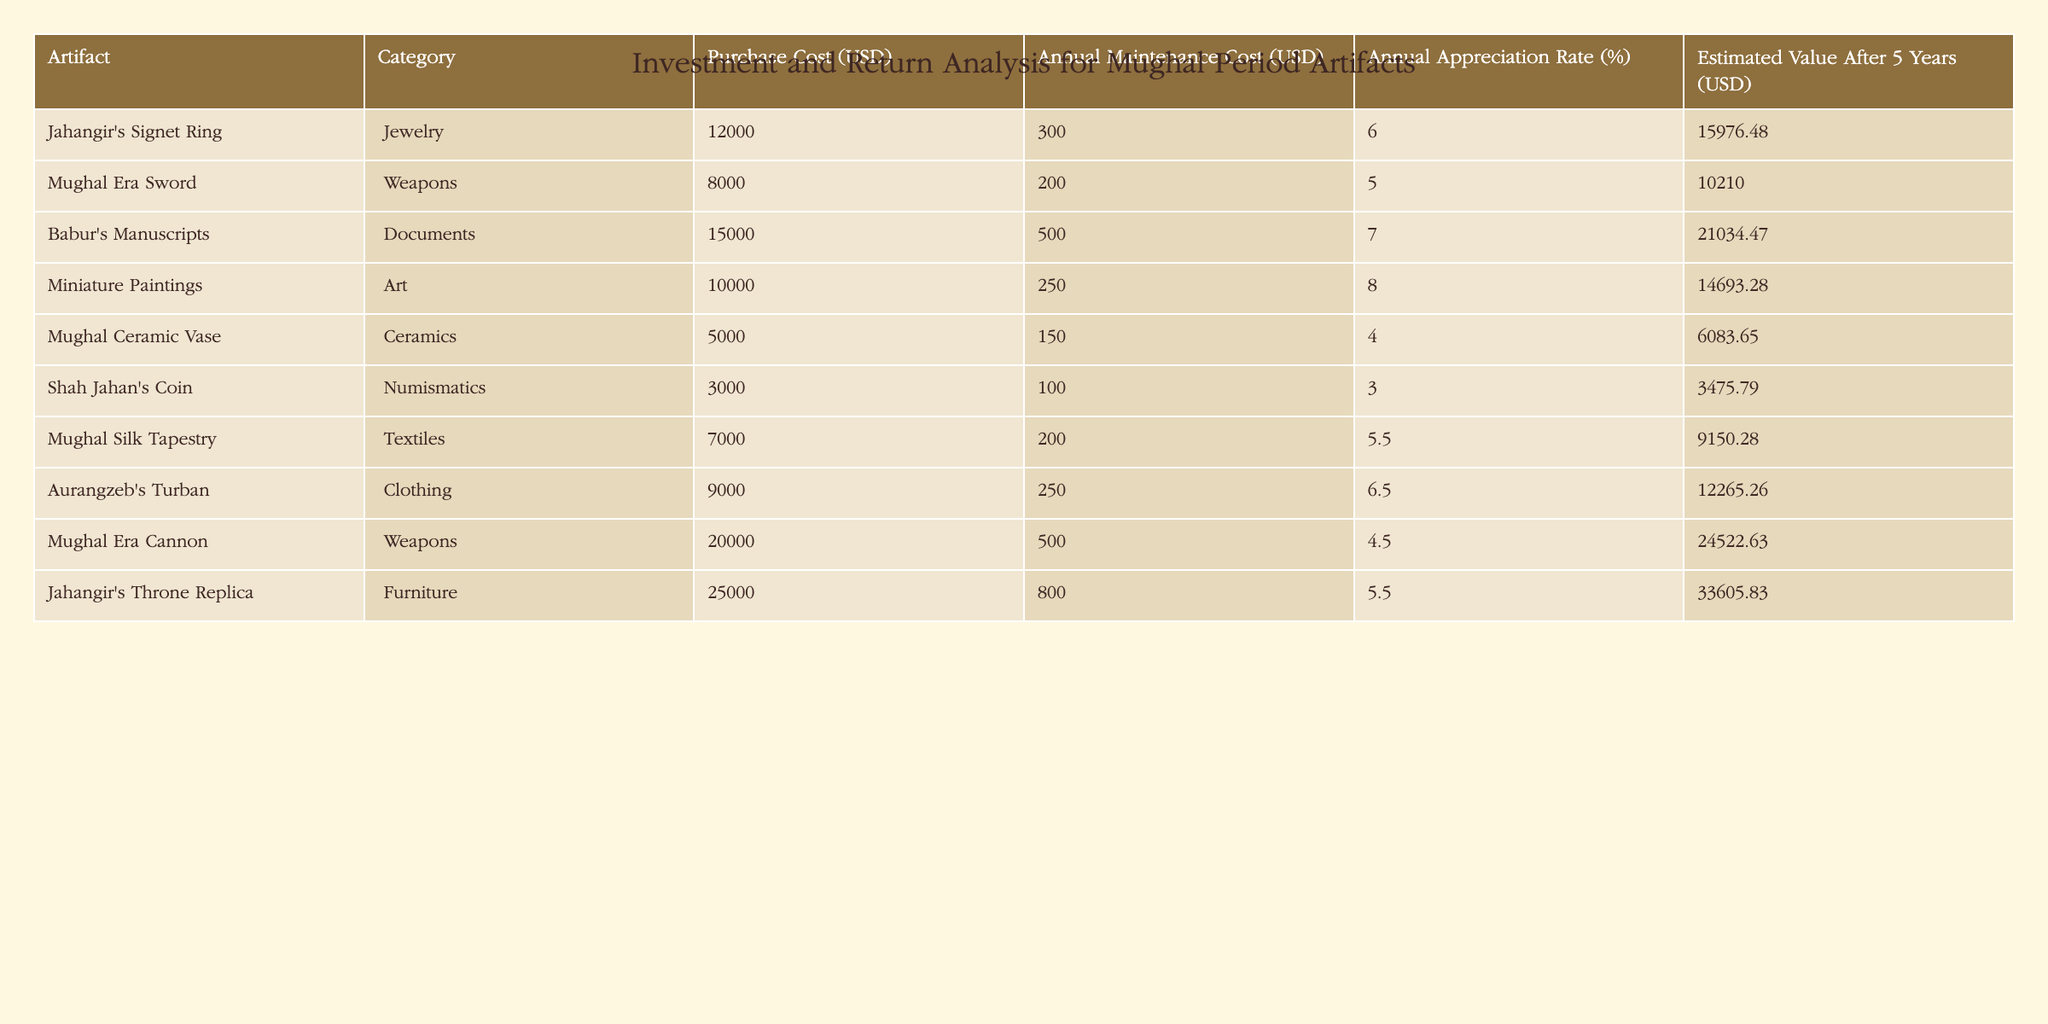What is the purchase cost of Jahangir's Signet Ring? The table shows the purchase cost for each artifact. For Jahangir's Signet Ring, it is explicitly listed under the "Purchase Cost (USD)" column as 12000.
Answer: 12000 What is the estimated value of the Mughal Era Cannon after 5 years? The estimated value of each artifact after 5 years is found in the last column of the table. For the Mughal Era Cannon, the value is listed as 24522.63.
Answer: 24522.63 What is the total annual maintenance cost for all the artifacts? To find the total annual maintenance cost, I add the annual maintenance costs from each row: 300 + 200 + 500 + 250 + 150 + 100 + 200 + 250 + 500 + 800 = 2950.
Answer: 2950 Is the annual appreciation rate for Babur's Manuscripts higher than that of the Mughal Ceramic Vase? Babur's Manuscripts has an annual appreciation rate of 7%, while the Mughal Ceramic Vase has an annual appreciation rate of 4%. Since 7% is greater than 4%, the statement is true.
Answer: Yes Which artifact has the highest estimated value after 5 years, and what is that value? I will compare the estimated values after 5 years for each artifact and find the maximum. The Jahangir's Throne Replica has the highest value at 33605.83.
Answer: Jahangir's Throne Replica, 33605.83 What is the difference in purchase cost between the Mughal Era Sword and the Aurangzeb's Turban? The purchase cost of the Mughal Era Sword is 8000 and that of Aurangzeb's Turban is 9000. The difference is calculated as 9000 - 8000 = 1000.
Answer: 1000 Are there any artifacts in the 'Documents' category that have an annual maintenance cost over 500? The category 'Documents' includes only Babur's Manuscripts, which has an annual maintenance cost of 500, which does not exceed 500. Therefore, there are no such artifacts.
Answer: No What is the average annual appreciation rate across all artifacts? To find the average, I sum the appreciation rates (6 + 5 + 7 + 8 + 4 + 3 + 5.5 + 6.5 + 4.5 + 5.5 = 56) and divide by the number of artifacts (10), resulting in 56 / 10 = 5.6.
Answer: 5.6 Which artifact has the lowest annual maintenance cost, and how much is it? The annual maintenance costs are listed, and I find that Shah Jahan's Coin has the lowest cost of 100.
Answer: Shah Jahan's Coin, 100 